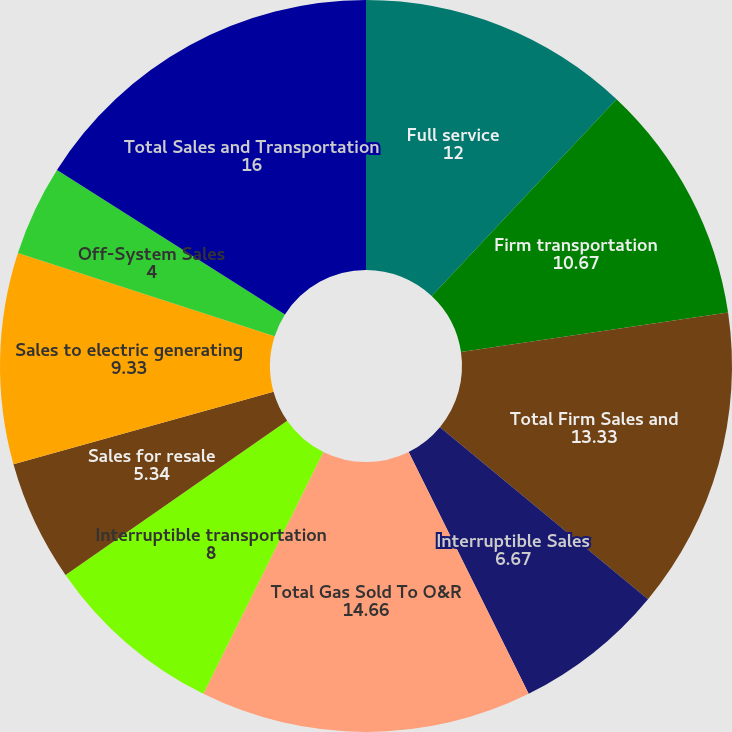Convert chart to OTSL. <chart><loc_0><loc_0><loc_500><loc_500><pie_chart><fcel>Full service<fcel>Firm transportation<fcel>Total Firm Sales and<fcel>Interruptible Sales<fcel>Total Gas Sold To O&R<fcel>Interruptible transportation<fcel>Sales for resale<fcel>Sales to electric generating<fcel>Off-System Sales<fcel>Total Sales and Transportation<nl><fcel>12.0%<fcel>10.67%<fcel>13.33%<fcel>6.67%<fcel>14.66%<fcel>8.0%<fcel>5.34%<fcel>9.33%<fcel>4.0%<fcel>16.0%<nl></chart> 